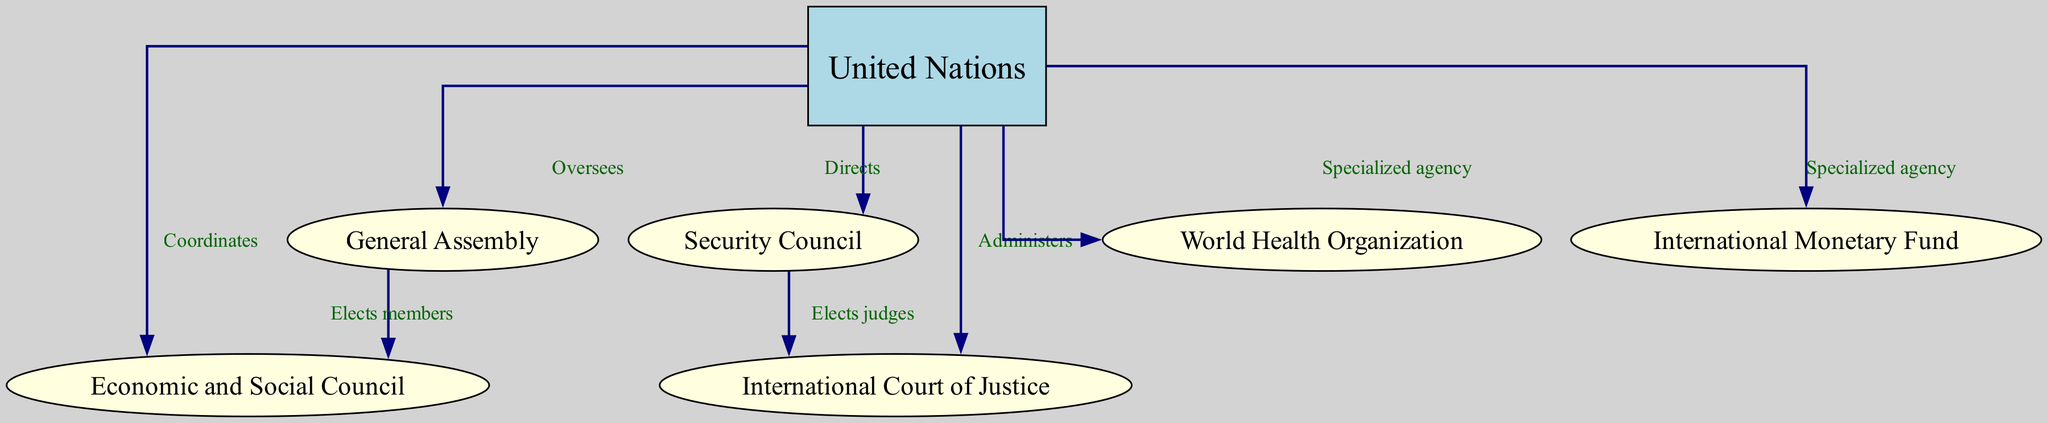What is the highest authority in the diagram? The diagram identifies the United Nations as the highest entity, which oversees and coordinates multiple other organizations. It is represented at the top of the hierarchy.
Answer: United Nations How many specialized agencies are directly under the United Nations? The diagram shows that the United Nations has two specialized agencies: the World Health Organization and the International Monetary Fund. These are indicated by arrows pointing from the UN to each of these agencies.
Answer: 2 Which organization does the General Assembly elect members to? The diagram specifies that the General Assembly elects members to the Economic and Social Council, as indicated by the arrow from GA to ECOSOC labeled "Elects members."
Answer: Economic and Social Council What role does the Security Council play concerning the International Court of Justice? The diagram indicates that the Security Council elects judges to the International Court of Justice, as shown by the directed arrow labeled "Elects judges" from the SC to ICJ.
Answer: Elects judges Which two councils does the United Nations coordinate? The diagram shows that the United Nations coordinates both the General Assembly and the Economic and Social Council, as shown by the directed arrows from the UN to GA and ECOSOC labeled respectively.
Answer: General Assembly, Economic and Social Council Which organization does the UN administer? The diagram indicates that the United Nations administers the International Court of Justice, identified by the arrow labeled "Administers" pointing from the UN to ICJ.
Answer: International Court of Justice In total, how many nodes are present in the diagram? The diagram lists a total of seven nodes, which include the United Nations, General Assembly, Security Council, Economic and Social Council, International Court of Justice, World Health Organization, and International Monetary Fund.
Answer: 7 What does the United Nations direct? The diagram specifically states that the United Nations directs the Security Council, as shown by the arrow labeled "Directs" pointing from UN to SC.
Answer: Security Council How many edges are there in the diagram connecting different organizations? The diagram depicts a total of eight edges that represent the various lines of authority and communication among the organizations. Each arrow between the nodes counts as one edge.
Answer: 8 